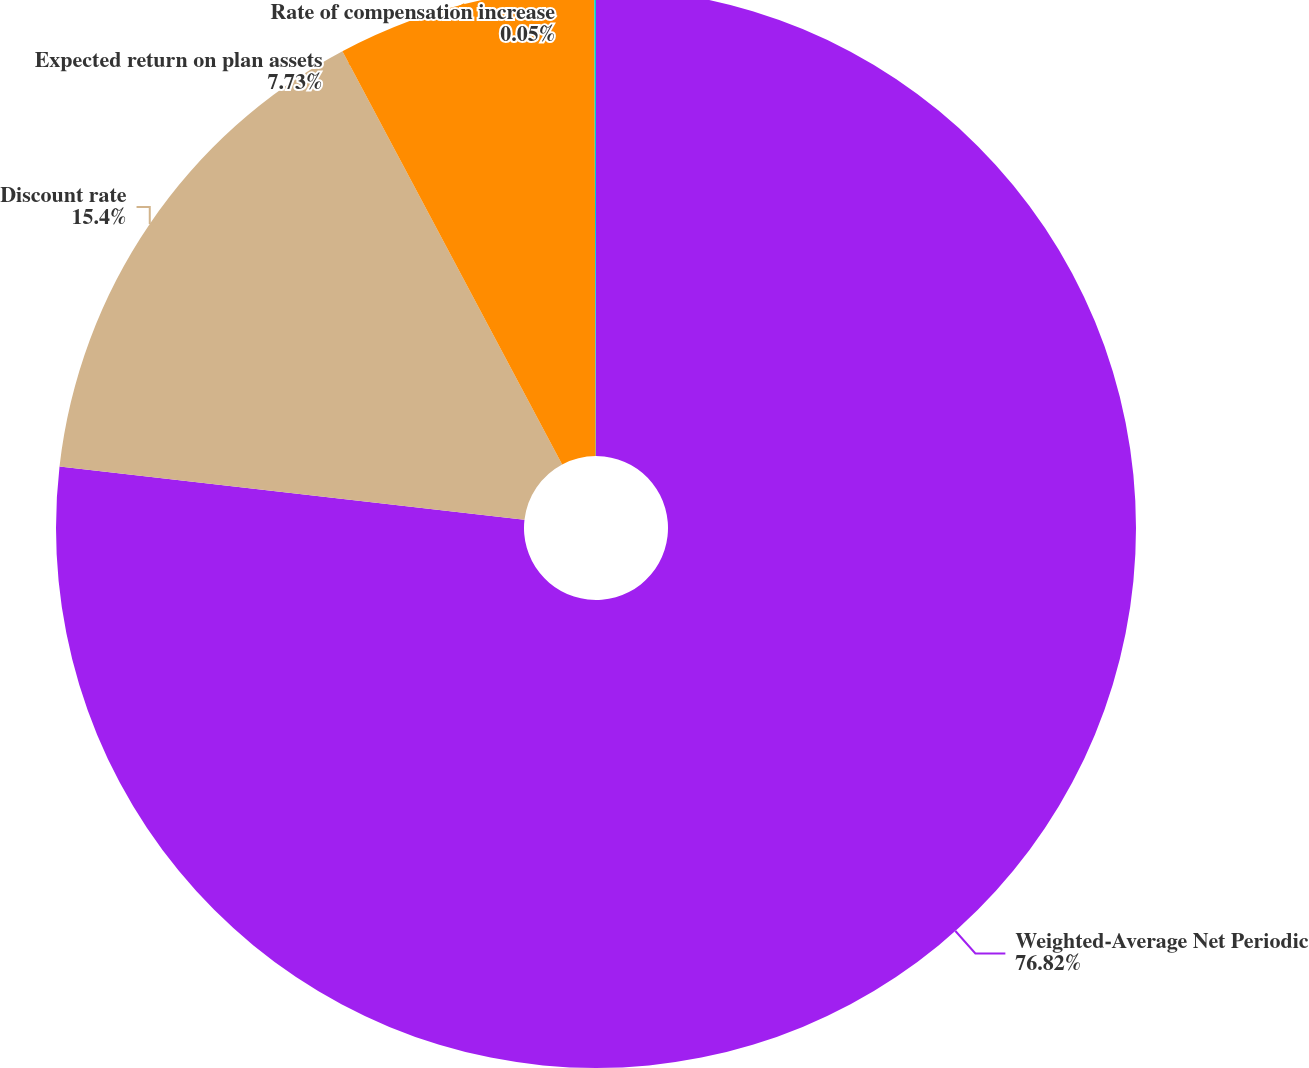<chart> <loc_0><loc_0><loc_500><loc_500><pie_chart><fcel>Weighted-Average Net Periodic<fcel>Discount rate<fcel>Expected return on plan assets<fcel>Rate of compensation increase<nl><fcel>76.82%<fcel>15.4%<fcel>7.73%<fcel>0.05%<nl></chart> 